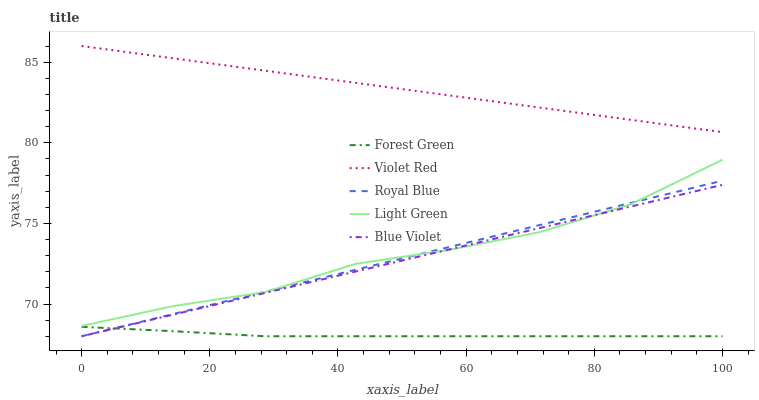Does Forest Green have the minimum area under the curve?
Answer yes or no. Yes. Does Violet Red have the maximum area under the curve?
Answer yes or no. Yes. Does Royal Blue have the minimum area under the curve?
Answer yes or no. No. Does Royal Blue have the maximum area under the curve?
Answer yes or no. No. Is Royal Blue the smoothest?
Answer yes or no. Yes. Is Light Green the roughest?
Answer yes or no. Yes. Is Forest Green the smoothest?
Answer yes or no. No. Is Forest Green the roughest?
Answer yes or no. No. Does Blue Violet have the lowest value?
Answer yes or no. Yes. Does Violet Red have the lowest value?
Answer yes or no. No. Does Violet Red have the highest value?
Answer yes or no. Yes. Does Royal Blue have the highest value?
Answer yes or no. No. Is Blue Violet less than Violet Red?
Answer yes or no. Yes. Is Violet Red greater than Blue Violet?
Answer yes or no. Yes. Does Blue Violet intersect Light Green?
Answer yes or no. Yes. Is Blue Violet less than Light Green?
Answer yes or no. No. Is Blue Violet greater than Light Green?
Answer yes or no. No. Does Blue Violet intersect Violet Red?
Answer yes or no. No. 